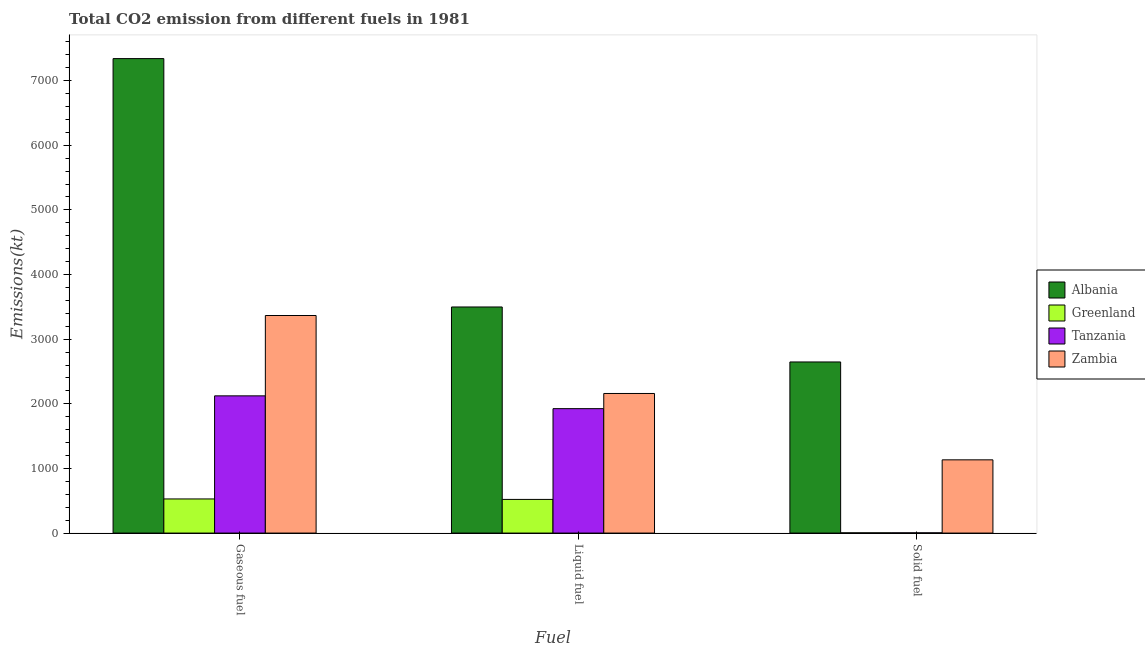Are the number of bars per tick equal to the number of legend labels?
Provide a short and direct response. Yes. Are the number of bars on each tick of the X-axis equal?
Give a very brief answer. Yes. How many bars are there on the 2nd tick from the left?
Your answer should be compact. 4. What is the label of the 2nd group of bars from the left?
Your answer should be very brief. Liquid fuel. What is the amount of co2 emissions from gaseous fuel in Albania?
Your answer should be very brief. 7341.33. Across all countries, what is the maximum amount of co2 emissions from gaseous fuel?
Offer a very short reply. 7341.33. Across all countries, what is the minimum amount of co2 emissions from liquid fuel?
Your answer should be compact. 520.71. In which country was the amount of co2 emissions from solid fuel maximum?
Make the answer very short. Albania. In which country was the amount of co2 emissions from gaseous fuel minimum?
Your answer should be very brief. Greenland. What is the total amount of co2 emissions from gaseous fuel in the graph?
Your answer should be very brief. 1.34e+04. What is the difference between the amount of co2 emissions from solid fuel in Albania and that in Zambia?
Keep it short and to the point. 1514.47. What is the difference between the amount of co2 emissions from liquid fuel in Albania and the amount of co2 emissions from gaseous fuel in Tanzania?
Provide a short and direct response. 1375.12. What is the average amount of co2 emissions from liquid fuel per country?
Offer a very short reply. 2026.02. What is the difference between the amount of co2 emissions from solid fuel and amount of co2 emissions from liquid fuel in Tanzania?
Your response must be concise. -1921.51. In how many countries, is the amount of co2 emissions from liquid fuel greater than 5000 kt?
Your response must be concise. 0. What is the ratio of the amount of co2 emissions from liquid fuel in Albania to that in Tanzania?
Provide a succinct answer. 1.82. What is the difference between the highest and the second highest amount of co2 emissions from liquid fuel?
Provide a short and direct response. 1338.46. What is the difference between the highest and the lowest amount of co2 emissions from gaseous fuel?
Give a very brief answer. 6813.29. In how many countries, is the amount of co2 emissions from liquid fuel greater than the average amount of co2 emissions from liquid fuel taken over all countries?
Give a very brief answer. 2. What does the 1st bar from the left in Gaseous fuel represents?
Your answer should be compact. Albania. What does the 4th bar from the right in Gaseous fuel represents?
Give a very brief answer. Albania. Is it the case that in every country, the sum of the amount of co2 emissions from gaseous fuel and amount of co2 emissions from liquid fuel is greater than the amount of co2 emissions from solid fuel?
Keep it short and to the point. Yes. Are all the bars in the graph horizontal?
Provide a succinct answer. No. What is the difference between two consecutive major ticks on the Y-axis?
Keep it short and to the point. 1000. Does the graph contain any zero values?
Offer a very short reply. No. How are the legend labels stacked?
Provide a short and direct response. Vertical. What is the title of the graph?
Offer a terse response. Total CO2 emission from different fuels in 1981. What is the label or title of the X-axis?
Your response must be concise. Fuel. What is the label or title of the Y-axis?
Offer a terse response. Emissions(kt). What is the Emissions(kt) of Albania in Gaseous fuel?
Provide a succinct answer. 7341.33. What is the Emissions(kt) in Greenland in Gaseous fuel?
Keep it short and to the point. 528.05. What is the Emissions(kt) in Tanzania in Gaseous fuel?
Keep it short and to the point. 2123.19. What is the Emissions(kt) in Zambia in Gaseous fuel?
Give a very brief answer. 3366.31. What is the Emissions(kt) in Albania in Liquid fuel?
Make the answer very short. 3498.32. What is the Emissions(kt) in Greenland in Liquid fuel?
Your answer should be very brief. 520.71. What is the Emissions(kt) of Tanzania in Liquid fuel?
Your response must be concise. 1925.17. What is the Emissions(kt) of Zambia in Liquid fuel?
Offer a very short reply. 2159.86. What is the Emissions(kt) in Albania in Solid fuel?
Make the answer very short. 2647.57. What is the Emissions(kt) of Greenland in Solid fuel?
Keep it short and to the point. 3.67. What is the Emissions(kt) in Tanzania in Solid fuel?
Ensure brevity in your answer.  3.67. What is the Emissions(kt) of Zambia in Solid fuel?
Offer a very short reply. 1133.1. Across all Fuel, what is the maximum Emissions(kt) of Albania?
Your response must be concise. 7341.33. Across all Fuel, what is the maximum Emissions(kt) in Greenland?
Offer a terse response. 528.05. Across all Fuel, what is the maximum Emissions(kt) of Tanzania?
Offer a terse response. 2123.19. Across all Fuel, what is the maximum Emissions(kt) of Zambia?
Your response must be concise. 3366.31. Across all Fuel, what is the minimum Emissions(kt) in Albania?
Your response must be concise. 2647.57. Across all Fuel, what is the minimum Emissions(kt) of Greenland?
Your answer should be very brief. 3.67. Across all Fuel, what is the minimum Emissions(kt) in Tanzania?
Your response must be concise. 3.67. Across all Fuel, what is the minimum Emissions(kt) of Zambia?
Offer a terse response. 1133.1. What is the total Emissions(kt) of Albania in the graph?
Ensure brevity in your answer.  1.35e+04. What is the total Emissions(kt) in Greenland in the graph?
Offer a very short reply. 1052.43. What is the total Emissions(kt) in Tanzania in the graph?
Provide a short and direct response. 4052.03. What is the total Emissions(kt) of Zambia in the graph?
Keep it short and to the point. 6659.27. What is the difference between the Emissions(kt) of Albania in Gaseous fuel and that in Liquid fuel?
Your answer should be compact. 3843.02. What is the difference between the Emissions(kt) in Greenland in Gaseous fuel and that in Liquid fuel?
Give a very brief answer. 7.33. What is the difference between the Emissions(kt) in Tanzania in Gaseous fuel and that in Liquid fuel?
Your response must be concise. 198.02. What is the difference between the Emissions(kt) of Zambia in Gaseous fuel and that in Liquid fuel?
Offer a terse response. 1206.44. What is the difference between the Emissions(kt) of Albania in Gaseous fuel and that in Solid fuel?
Give a very brief answer. 4693.76. What is the difference between the Emissions(kt) in Greenland in Gaseous fuel and that in Solid fuel?
Provide a short and direct response. 524.38. What is the difference between the Emissions(kt) in Tanzania in Gaseous fuel and that in Solid fuel?
Provide a short and direct response. 2119.53. What is the difference between the Emissions(kt) of Zambia in Gaseous fuel and that in Solid fuel?
Offer a terse response. 2233.2. What is the difference between the Emissions(kt) of Albania in Liquid fuel and that in Solid fuel?
Make the answer very short. 850.74. What is the difference between the Emissions(kt) in Greenland in Liquid fuel and that in Solid fuel?
Your response must be concise. 517.05. What is the difference between the Emissions(kt) of Tanzania in Liquid fuel and that in Solid fuel?
Offer a very short reply. 1921.51. What is the difference between the Emissions(kt) of Zambia in Liquid fuel and that in Solid fuel?
Provide a succinct answer. 1026.76. What is the difference between the Emissions(kt) of Albania in Gaseous fuel and the Emissions(kt) of Greenland in Liquid fuel?
Keep it short and to the point. 6820.62. What is the difference between the Emissions(kt) of Albania in Gaseous fuel and the Emissions(kt) of Tanzania in Liquid fuel?
Provide a succinct answer. 5416.16. What is the difference between the Emissions(kt) in Albania in Gaseous fuel and the Emissions(kt) in Zambia in Liquid fuel?
Keep it short and to the point. 5181.47. What is the difference between the Emissions(kt) in Greenland in Gaseous fuel and the Emissions(kt) in Tanzania in Liquid fuel?
Your response must be concise. -1397.13. What is the difference between the Emissions(kt) in Greenland in Gaseous fuel and the Emissions(kt) in Zambia in Liquid fuel?
Provide a short and direct response. -1631.82. What is the difference between the Emissions(kt) of Tanzania in Gaseous fuel and the Emissions(kt) of Zambia in Liquid fuel?
Give a very brief answer. -36.67. What is the difference between the Emissions(kt) of Albania in Gaseous fuel and the Emissions(kt) of Greenland in Solid fuel?
Give a very brief answer. 7337.67. What is the difference between the Emissions(kt) of Albania in Gaseous fuel and the Emissions(kt) of Tanzania in Solid fuel?
Your answer should be compact. 7337.67. What is the difference between the Emissions(kt) of Albania in Gaseous fuel and the Emissions(kt) of Zambia in Solid fuel?
Offer a very short reply. 6208.23. What is the difference between the Emissions(kt) of Greenland in Gaseous fuel and the Emissions(kt) of Tanzania in Solid fuel?
Provide a succinct answer. 524.38. What is the difference between the Emissions(kt) in Greenland in Gaseous fuel and the Emissions(kt) in Zambia in Solid fuel?
Make the answer very short. -605.05. What is the difference between the Emissions(kt) in Tanzania in Gaseous fuel and the Emissions(kt) in Zambia in Solid fuel?
Your answer should be very brief. 990.09. What is the difference between the Emissions(kt) of Albania in Liquid fuel and the Emissions(kt) of Greenland in Solid fuel?
Your answer should be very brief. 3494.65. What is the difference between the Emissions(kt) in Albania in Liquid fuel and the Emissions(kt) in Tanzania in Solid fuel?
Keep it short and to the point. 3494.65. What is the difference between the Emissions(kt) of Albania in Liquid fuel and the Emissions(kt) of Zambia in Solid fuel?
Provide a succinct answer. 2365.22. What is the difference between the Emissions(kt) in Greenland in Liquid fuel and the Emissions(kt) in Tanzania in Solid fuel?
Provide a short and direct response. 517.05. What is the difference between the Emissions(kt) of Greenland in Liquid fuel and the Emissions(kt) of Zambia in Solid fuel?
Give a very brief answer. -612.39. What is the difference between the Emissions(kt) in Tanzania in Liquid fuel and the Emissions(kt) in Zambia in Solid fuel?
Your response must be concise. 792.07. What is the average Emissions(kt) of Albania per Fuel?
Offer a very short reply. 4495.74. What is the average Emissions(kt) of Greenland per Fuel?
Your answer should be compact. 350.81. What is the average Emissions(kt) in Tanzania per Fuel?
Give a very brief answer. 1350.68. What is the average Emissions(kt) in Zambia per Fuel?
Provide a succinct answer. 2219.76. What is the difference between the Emissions(kt) in Albania and Emissions(kt) in Greenland in Gaseous fuel?
Your response must be concise. 6813.29. What is the difference between the Emissions(kt) of Albania and Emissions(kt) of Tanzania in Gaseous fuel?
Provide a succinct answer. 5218.14. What is the difference between the Emissions(kt) in Albania and Emissions(kt) in Zambia in Gaseous fuel?
Ensure brevity in your answer.  3975.03. What is the difference between the Emissions(kt) of Greenland and Emissions(kt) of Tanzania in Gaseous fuel?
Make the answer very short. -1595.14. What is the difference between the Emissions(kt) of Greenland and Emissions(kt) of Zambia in Gaseous fuel?
Offer a very short reply. -2838.26. What is the difference between the Emissions(kt) in Tanzania and Emissions(kt) in Zambia in Gaseous fuel?
Keep it short and to the point. -1243.11. What is the difference between the Emissions(kt) in Albania and Emissions(kt) in Greenland in Liquid fuel?
Give a very brief answer. 2977.6. What is the difference between the Emissions(kt) in Albania and Emissions(kt) in Tanzania in Liquid fuel?
Offer a terse response. 1573.14. What is the difference between the Emissions(kt) of Albania and Emissions(kt) of Zambia in Liquid fuel?
Ensure brevity in your answer.  1338.45. What is the difference between the Emissions(kt) in Greenland and Emissions(kt) in Tanzania in Liquid fuel?
Keep it short and to the point. -1404.46. What is the difference between the Emissions(kt) in Greenland and Emissions(kt) in Zambia in Liquid fuel?
Keep it short and to the point. -1639.15. What is the difference between the Emissions(kt) in Tanzania and Emissions(kt) in Zambia in Liquid fuel?
Make the answer very short. -234.69. What is the difference between the Emissions(kt) in Albania and Emissions(kt) in Greenland in Solid fuel?
Keep it short and to the point. 2643.91. What is the difference between the Emissions(kt) in Albania and Emissions(kt) in Tanzania in Solid fuel?
Make the answer very short. 2643.91. What is the difference between the Emissions(kt) in Albania and Emissions(kt) in Zambia in Solid fuel?
Provide a succinct answer. 1514.47. What is the difference between the Emissions(kt) of Greenland and Emissions(kt) of Zambia in Solid fuel?
Provide a short and direct response. -1129.44. What is the difference between the Emissions(kt) in Tanzania and Emissions(kt) in Zambia in Solid fuel?
Keep it short and to the point. -1129.44. What is the ratio of the Emissions(kt) in Albania in Gaseous fuel to that in Liquid fuel?
Ensure brevity in your answer.  2.1. What is the ratio of the Emissions(kt) in Greenland in Gaseous fuel to that in Liquid fuel?
Offer a terse response. 1.01. What is the ratio of the Emissions(kt) in Tanzania in Gaseous fuel to that in Liquid fuel?
Ensure brevity in your answer.  1.1. What is the ratio of the Emissions(kt) of Zambia in Gaseous fuel to that in Liquid fuel?
Give a very brief answer. 1.56. What is the ratio of the Emissions(kt) of Albania in Gaseous fuel to that in Solid fuel?
Make the answer very short. 2.77. What is the ratio of the Emissions(kt) in Greenland in Gaseous fuel to that in Solid fuel?
Keep it short and to the point. 144. What is the ratio of the Emissions(kt) of Tanzania in Gaseous fuel to that in Solid fuel?
Offer a very short reply. 579. What is the ratio of the Emissions(kt) of Zambia in Gaseous fuel to that in Solid fuel?
Keep it short and to the point. 2.97. What is the ratio of the Emissions(kt) of Albania in Liquid fuel to that in Solid fuel?
Keep it short and to the point. 1.32. What is the ratio of the Emissions(kt) in Greenland in Liquid fuel to that in Solid fuel?
Provide a succinct answer. 142. What is the ratio of the Emissions(kt) of Tanzania in Liquid fuel to that in Solid fuel?
Ensure brevity in your answer.  525. What is the ratio of the Emissions(kt) in Zambia in Liquid fuel to that in Solid fuel?
Your response must be concise. 1.91. What is the difference between the highest and the second highest Emissions(kt) in Albania?
Ensure brevity in your answer.  3843.02. What is the difference between the highest and the second highest Emissions(kt) of Greenland?
Provide a short and direct response. 7.33. What is the difference between the highest and the second highest Emissions(kt) of Tanzania?
Your answer should be very brief. 198.02. What is the difference between the highest and the second highest Emissions(kt) in Zambia?
Offer a terse response. 1206.44. What is the difference between the highest and the lowest Emissions(kt) in Albania?
Ensure brevity in your answer.  4693.76. What is the difference between the highest and the lowest Emissions(kt) in Greenland?
Provide a short and direct response. 524.38. What is the difference between the highest and the lowest Emissions(kt) of Tanzania?
Provide a short and direct response. 2119.53. What is the difference between the highest and the lowest Emissions(kt) of Zambia?
Your response must be concise. 2233.2. 